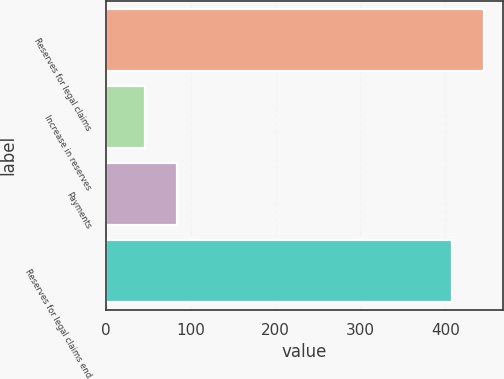Convert chart to OTSL. <chart><loc_0><loc_0><loc_500><loc_500><bar_chart><fcel>Reserves for legal claims<fcel>Increase in reserves<fcel>Payments<fcel>Reserves for legal claims end<nl><fcel>445.52<fcel>46.4<fcel>83.82<fcel>408.1<nl></chart> 